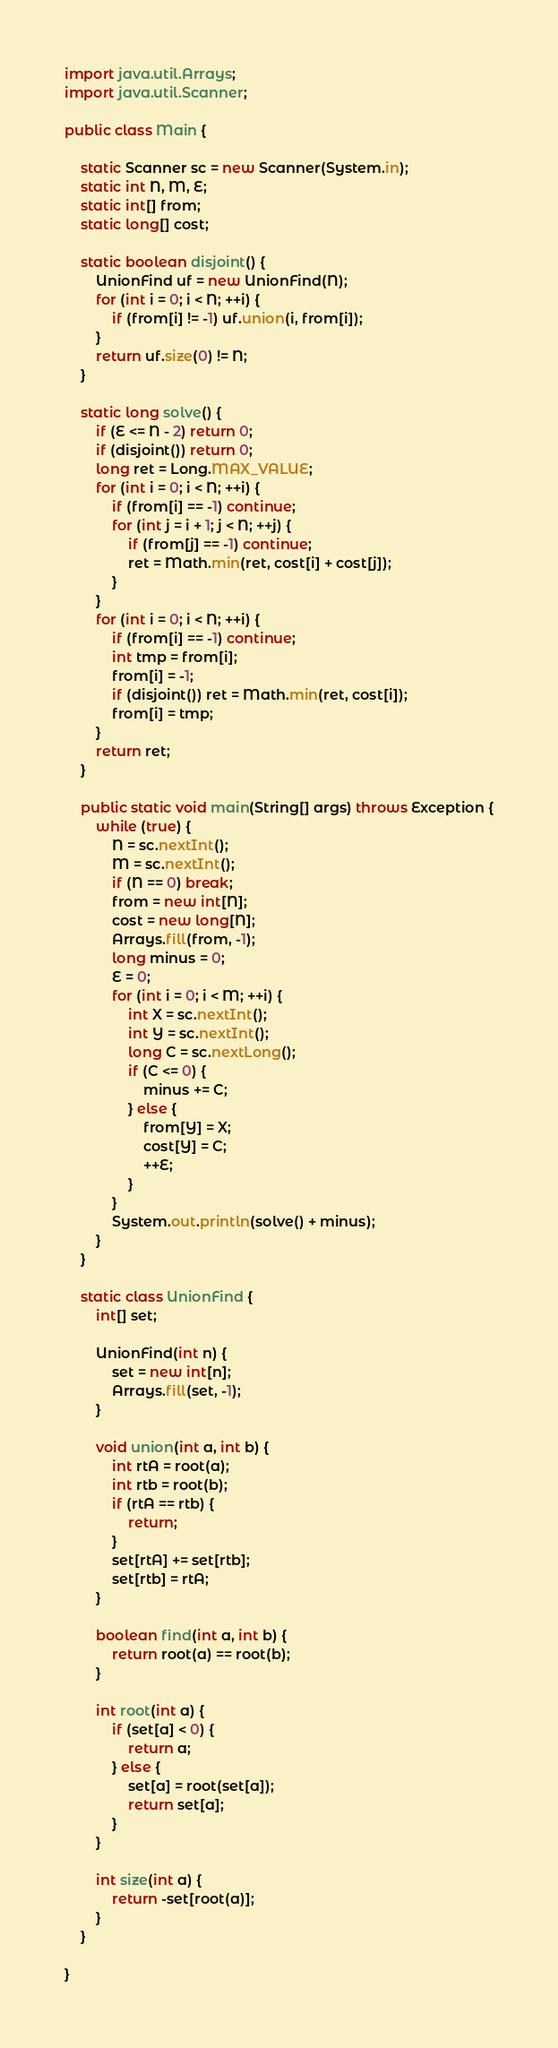<code> <loc_0><loc_0><loc_500><loc_500><_Java_>import java.util.Arrays;
import java.util.Scanner;

public class Main {

	static Scanner sc = new Scanner(System.in);
	static int N, M, E;
	static int[] from;
	static long[] cost;

	static boolean disjoint() {
		UnionFind uf = new UnionFind(N);
		for (int i = 0; i < N; ++i) {
			if (from[i] != -1) uf.union(i, from[i]);
		}
		return uf.size(0) != N;
	}

	static long solve() {
		if (E <= N - 2) return 0;
		if (disjoint()) return 0;
		long ret = Long.MAX_VALUE;
		for (int i = 0; i < N; ++i) {
			if (from[i] == -1) continue;
			for (int j = i + 1; j < N; ++j) {
				if (from[j] == -1) continue;
				ret = Math.min(ret, cost[i] + cost[j]);
			}
		}
		for (int i = 0; i < N; ++i) {
			if (from[i] == -1) continue;
			int tmp = from[i];
			from[i] = -1;
			if (disjoint()) ret = Math.min(ret, cost[i]);
			from[i] = tmp;
		}
		return ret;
	}

	public static void main(String[] args) throws Exception {
		while (true) {
			N = sc.nextInt();
			M = sc.nextInt();
			if (N == 0) break;
			from = new int[N];
			cost = new long[N];
			Arrays.fill(from, -1);
			long minus = 0;
			E = 0;
			for (int i = 0; i < M; ++i) {
				int X = sc.nextInt();
				int Y = sc.nextInt();
				long C = sc.nextLong();
				if (C <= 0) {
					minus += C;
				} else {
					from[Y] = X;
					cost[Y] = C;
					++E;
				}
			}
			System.out.println(solve() + minus);
		}
	}

	static class UnionFind {
		int[] set;

		UnionFind(int n) {
			set = new int[n];
			Arrays.fill(set, -1);
		}

		void union(int a, int b) {
			int rtA = root(a);
			int rtb = root(b);
			if (rtA == rtb) {
				return;
			}
			set[rtA] += set[rtb];
			set[rtb] = rtA;
		}

		boolean find(int a, int b) {
			return root(a) == root(b);
		}

		int root(int a) {
			if (set[a] < 0) {
				return a;
			} else {
				set[a] = root(set[a]);
				return set[a];
			}
		}

		int size(int a) {
			return -set[root(a)];
		}
	}

}</code> 